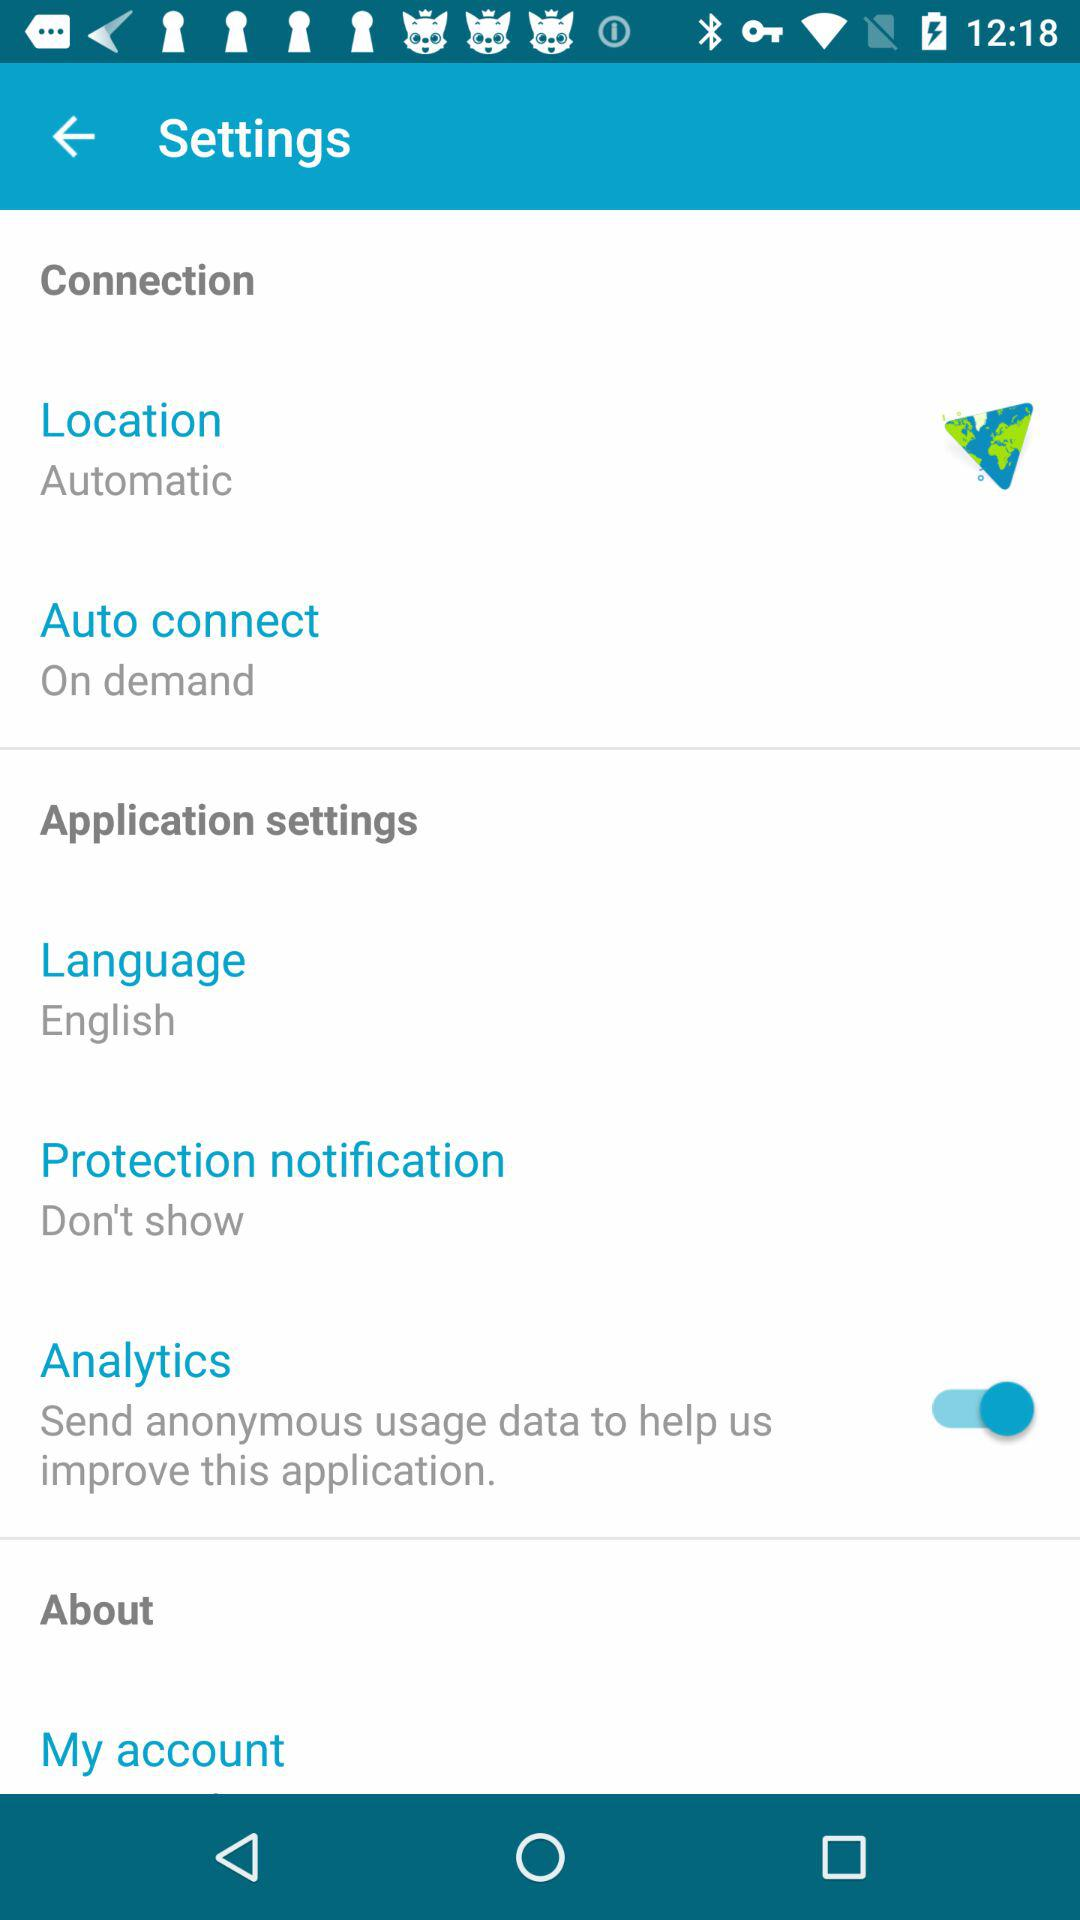What is the selected language? The selected language is English. 